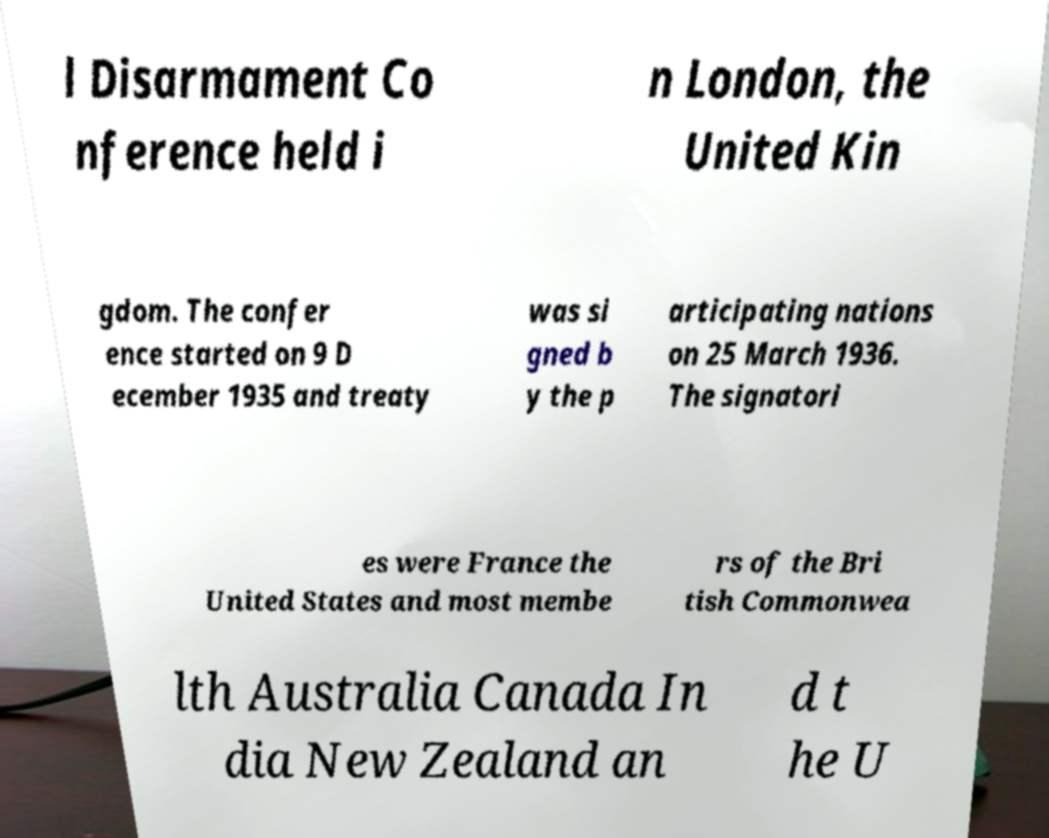Please read and relay the text visible in this image. What does it say? l Disarmament Co nference held i n London, the United Kin gdom. The confer ence started on 9 D ecember 1935 and treaty was si gned b y the p articipating nations on 25 March 1936. The signatori es were France the United States and most membe rs of the Bri tish Commonwea lth Australia Canada In dia New Zealand an d t he U 